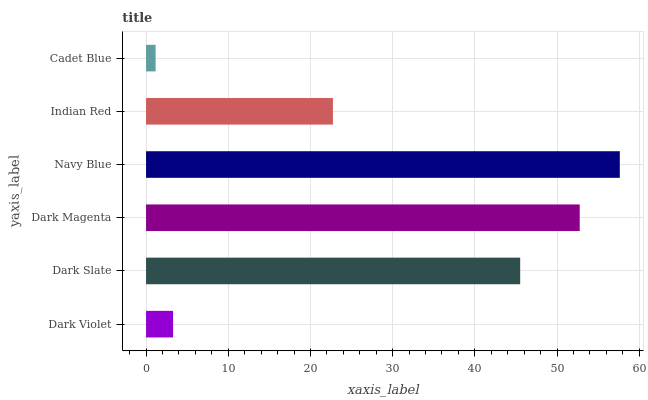Is Cadet Blue the minimum?
Answer yes or no. Yes. Is Navy Blue the maximum?
Answer yes or no. Yes. Is Dark Slate the minimum?
Answer yes or no. No. Is Dark Slate the maximum?
Answer yes or no. No. Is Dark Slate greater than Dark Violet?
Answer yes or no. Yes. Is Dark Violet less than Dark Slate?
Answer yes or no. Yes. Is Dark Violet greater than Dark Slate?
Answer yes or no. No. Is Dark Slate less than Dark Violet?
Answer yes or no. No. Is Dark Slate the high median?
Answer yes or no. Yes. Is Indian Red the low median?
Answer yes or no. Yes. Is Dark Magenta the high median?
Answer yes or no. No. Is Navy Blue the low median?
Answer yes or no. No. 